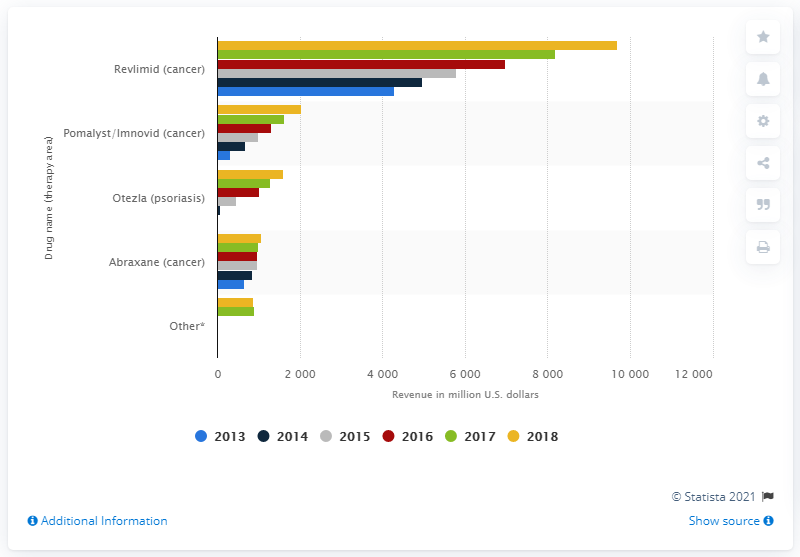Specify some key components in this picture. In 2014, Otezla generated $69.8 million in revenue. Until 2018, the annual revenue of Otezla was 1614. 